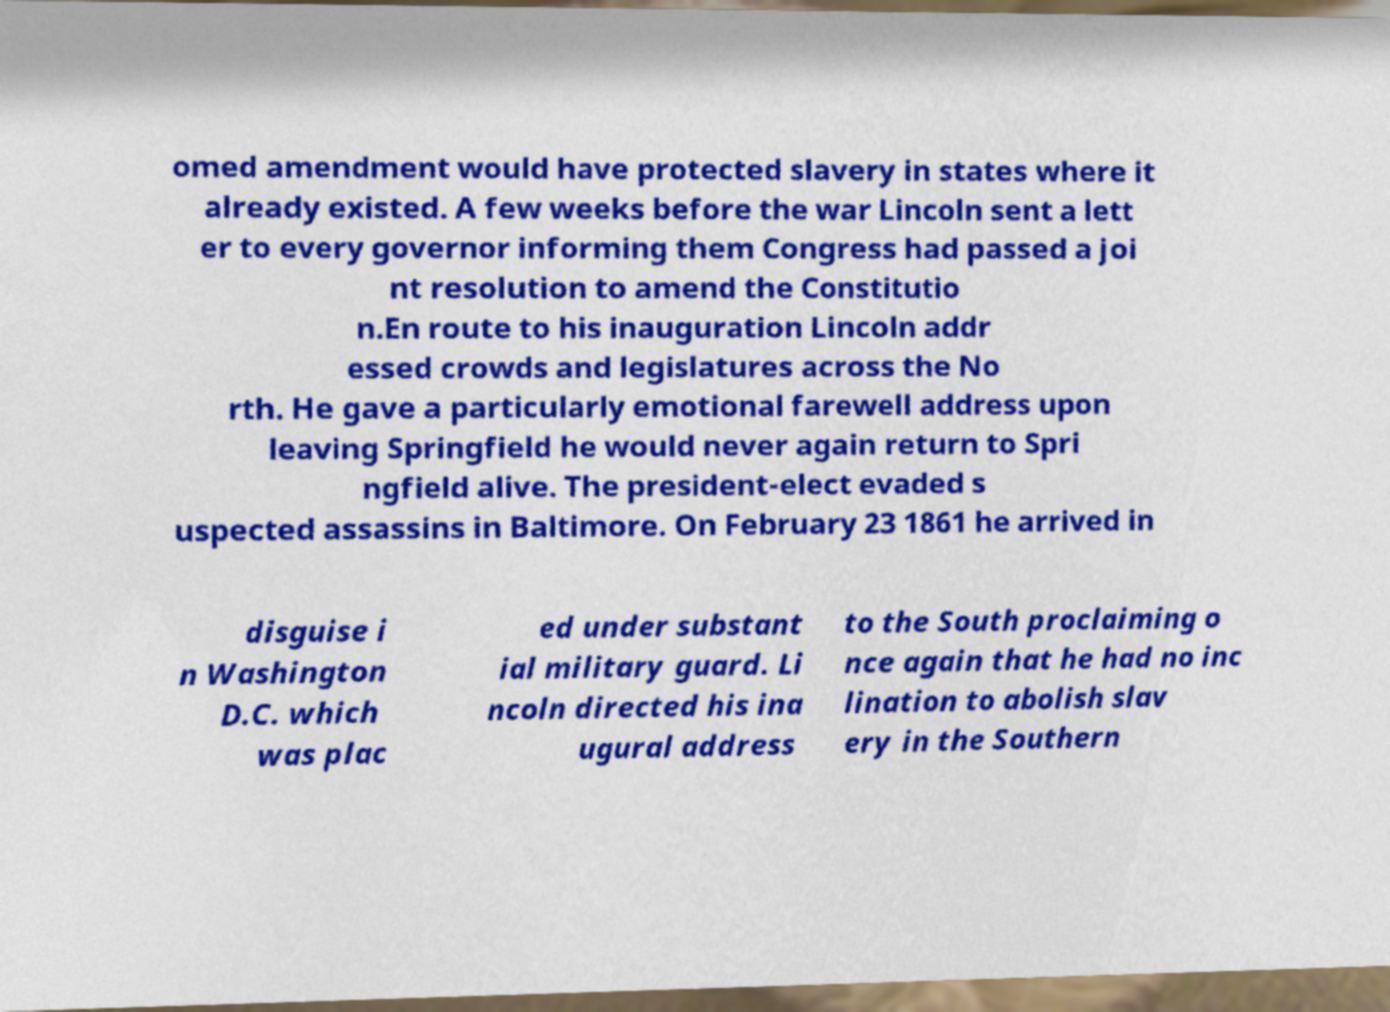I need the written content from this picture converted into text. Can you do that? omed amendment would have protected slavery in states where it already existed. A few weeks before the war Lincoln sent a lett er to every governor informing them Congress had passed a joi nt resolution to amend the Constitutio n.En route to his inauguration Lincoln addr essed crowds and legislatures across the No rth. He gave a particularly emotional farewell address upon leaving Springfield he would never again return to Spri ngfield alive. The president-elect evaded s uspected assassins in Baltimore. On February 23 1861 he arrived in disguise i n Washington D.C. which was plac ed under substant ial military guard. Li ncoln directed his ina ugural address to the South proclaiming o nce again that he had no inc lination to abolish slav ery in the Southern 